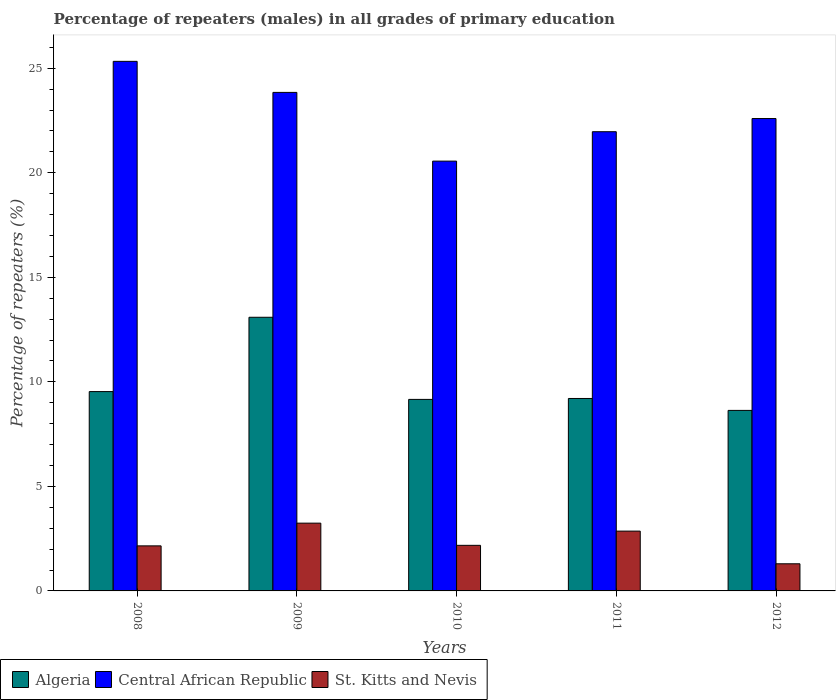How many groups of bars are there?
Ensure brevity in your answer.  5. Are the number of bars on each tick of the X-axis equal?
Your answer should be very brief. Yes. How many bars are there on the 3rd tick from the left?
Keep it short and to the point. 3. What is the label of the 5th group of bars from the left?
Your answer should be compact. 2012. What is the percentage of repeaters (males) in Algeria in 2009?
Your answer should be very brief. 13.09. Across all years, what is the maximum percentage of repeaters (males) in St. Kitts and Nevis?
Ensure brevity in your answer.  3.24. Across all years, what is the minimum percentage of repeaters (males) in St. Kitts and Nevis?
Ensure brevity in your answer.  1.3. In which year was the percentage of repeaters (males) in Central African Republic minimum?
Offer a very short reply. 2010. What is the total percentage of repeaters (males) in Central African Republic in the graph?
Ensure brevity in your answer.  114.28. What is the difference between the percentage of repeaters (males) in Algeria in 2008 and that in 2010?
Keep it short and to the point. 0.37. What is the difference between the percentage of repeaters (males) in Central African Republic in 2011 and the percentage of repeaters (males) in St. Kitts and Nevis in 2012?
Give a very brief answer. 20.66. What is the average percentage of repeaters (males) in Central African Republic per year?
Keep it short and to the point. 22.86. In the year 2008, what is the difference between the percentage of repeaters (males) in St. Kitts and Nevis and percentage of repeaters (males) in Central African Republic?
Give a very brief answer. -23.17. What is the ratio of the percentage of repeaters (males) in Central African Republic in 2008 to that in 2012?
Your answer should be compact. 1.12. Is the difference between the percentage of repeaters (males) in St. Kitts and Nevis in 2009 and 2011 greater than the difference between the percentage of repeaters (males) in Central African Republic in 2009 and 2011?
Provide a succinct answer. No. What is the difference between the highest and the second highest percentage of repeaters (males) in Algeria?
Provide a short and direct response. 3.55. What is the difference between the highest and the lowest percentage of repeaters (males) in St. Kitts and Nevis?
Your answer should be compact. 1.94. Is the sum of the percentage of repeaters (males) in St. Kitts and Nevis in 2008 and 2009 greater than the maximum percentage of repeaters (males) in Algeria across all years?
Your response must be concise. No. What does the 2nd bar from the left in 2010 represents?
Offer a terse response. Central African Republic. What does the 1st bar from the right in 2010 represents?
Provide a succinct answer. St. Kitts and Nevis. Are the values on the major ticks of Y-axis written in scientific E-notation?
Offer a very short reply. No. How are the legend labels stacked?
Offer a terse response. Horizontal. What is the title of the graph?
Make the answer very short. Percentage of repeaters (males) in all grades of primary education. Does "Albania" appear as one of the legend labels in the graph?
Make the answer very short. No. What is the label or title of the Y-axis?
Provide a succinct answer. Percentage of repeaters (%). What is the Percentage of repeaters (%) of Algeria in 2008?
Offer a very short reply. 9.53. What is the Percentage of repeaters (%) of Central African Republic in 2008?
Your answer should be very brief. 25.33. What is the Percentage of repeaters (%) in St. Kitts and Nevis in 2008?
Your answer should be compact. 2.15. What is the Percentage of repeaters (%) of Algeria in 2009?
Your answer should be very brief. 13.09. What is the Percentage of repeaters (%) of Central African Republic in 2009?
Ensure brevity in your answer.  23.84. What is the Percentage of repeaters (%) of St. Kitts and Nevis in 2009?
Provide a short and direct response. 3.24. What is the Percentage of repeaters (%) of Algeria in 2010?
Provide a short and direct response. 9.16. What is the Percentage of repeaters (%) in Central African Republic in 2010?
Ensure brevity in your answer.  20.56. What is the Percentage of repeaters (%) in St. Kitts and Nevis in 2010?
Give a very brief answer. 2.18. What is the Percentage of repeaters (%) in Algeria in 2011?
Provide a succinct answer. 9.2. What is the Percentage of repeaters (%) in Central African Republic in 2011?
Ensure brevity in your answer.  21.96. What is the Percentage of repeaters (%) in St. Kitts and Nevis in 2011?
Give a very brief answer. 2.86. What is the Percentage of repeaters (%) in Algeria in 2012?
Provide a succinct answer. 8.63. What is the Percentage of repeaters (%) of Central African Republic in 2012?
Provide a succinct answer. 22.59. What is the Percentage of repeaters (%) of St. Kitts and Nevis in 2012?
Your answer should be compact. 1.3. Across all years, what is the maximum Percentage of repeaters (%) of Algeria?
Your answer should be very brief. 13.09. Across all years, what is the maximum Percentage of repeaters (%) in Central African Republic?
Keep it short and to the point. 25.33. Across all years, what is the maximum Percentage of repeaters (%) in St. Kitts and Nevis?
Keep it short and to the point. 3.24. Across all years, what is the minimum Percentage of repeaters (%) in Algeria?
Keep it short and to the point. 8.63. Across all years, what is the minimum Percentage of repeaters (%) in Central African Republic?
Keep it short and to the point. 20.56. Across all years, what is the minimum Percentage of repeaters (%) of St. Kitts and Nevis?
Ensure brevity in your answer.  1.3. What is the total Percentage of repeaters (%) of Algeria in the graph?
Provide a succinct answer. 49.62. What is the total Percentage of repeaters (%) in Central African Republic in the graph?
Provide a succinct answer. 114.28. What is the total Percentage of repeaters (%) in St. Kitts and Nevis in the graph?
Your answer should be very brief. 11.73. What is the difference between the Percentage of repeaters (%) in Algeria in 2008 and that in 2009?
Your answer should be compact. -3.55. What is the difference between the Percentage of repeaters (%) of Central African Republic in 2008 and that in 2009?
Keep it short and to the point. 1.48. What is the difference between the Percentage of repeaters (%) of St. Kitts and Nevis in 2008 and that in 2009?
Your answer should be very brief. -1.09. What is the difference between the Percentage of repeaters (%) in Algeria in 2008 and that in 2010?
Your answer should be very brief. 0.37. What is the difference between the Percentage of repeaters (%) of Central African Republic in 2008 and that in 2010?
Give a very brief answer. 4.77. What is the difference between the Percentage of repeaters (%) of St. Kitts and Nevis in 2008 and that in 2010?
Your answer should be very brief. -0.03. What is the difference between the Percentage of repeaters (%) of Algeria in 2008 and that in 2011?
Offer a very short reply. 0.33. What is the difference between the Percentage of repeaters (%) of Central African Republic in 2008 and that in 2011?
Keep it short and to the point. 3.36. What is the difference between the Percentage of repeaters (%) in St. Kitts and Nevis in 2008 and that in 2011?
Your answer should be very brief. -0.71. What is the difference between the Percentage of repeaters (%) in Algeria in 2008 and that in 2012?
Give a very brief answer. 0.9. What is the difference between the Percentage of repeaters (%) of Central African Republic in 2008 and that in 2012?
Provide a succinct answer. 2.73. What is the difference between the Percentage of repeaters (%) of St. Kitts and Nevis in 2008 and that in 2012?
Keep it short and to the point. 0.86. What is the difference between the Percentage of repeaters (%) in Algeria in 2009 and that in 2010?
Your answer should be compact. 3.93. What is the difference between the Percentage of repeaters (%) of Central African Republic in 2009 and that in 2010?
Make the answer very short. 3.29. What is the difference between the Percentage of repeaters (%) of St. Kitts and Nevis in 2009 and that in 2010?
Give a very brief answer. 1.06. What is the difference between the Percentage of repeaters (%) of Algeria in 2009 and that in 2011?
Offer a terse response. 3.88. What is the difference between the Percentage of repeaters (%) of Central African Republic in 2009 and that in 2011?
Keep it short and to the point. 1.88. What is the difference between the Percentage of repeaters (%) of St. Kitts and Nevis in 2009 and that in 2011?
Make the answer very short. 0.38. What is the difference between the Percentage of repeaters (%) in Algeria in 2009 and that in 2012?
Keep it short and to the point. 4.45. What is the difference between the Percentage of repeaters (%) of Central African Republic in 2009 and that in 2012?
Your answer should be very brief. 1.25. What is the difference between the Percentage of repeaters (%) of St. Kitts and Nevis in 2009 and that in 2012?
Make the answer very short. 1.94. What is the difference between the Percentage of repeaters (%) in Algeria in 2010 and that in 2011?
Make the answer very short. -0.04. What is the difference between the Percentage of repeaters (%) in Central African Republic in 2010 and that in 2011?
Provide a short and direct response. -1.41. What is the difference between the Percentage of repeaters (%) in St. Kitts and Nevis in 2010 and that in 2011?
Offer a terse response. -0.68. What is the difference between the Percentage of repeaters (%) of Algeria in 2010 and that in 2012?
Offer a terse response. 0.53. What is the difference between the Percentage of repeaters (%) of Central African Republic in 2010 and that in 2012?
Give a very brief answer. -2.04. What is the difference between the Percentage of repeaters (%) of St. Kitts and Nevis in 2010 and that in 2012?
Keep it short and to the point. 0.88. What is the difference between the Percentage of repeaters (%) in Algeria in 2011 and that in 2012?
Offer a terse response. 0.57. What is the difference between the Percentage of repeaters (%) in Central African Republic in 2011 and that in 2012?
Give a very brief answer. -0.63. What is the difference between the Percentage of repeaters (%) of St. Kitts and Nevis in 2011 and that in 2012?
Your response must be concise. 1.56. What is the difference between the Percentage of repeaters (%) in Algeria in 2008 and the Percentage of repeaters (%) in Central African Republic in 2009?
Your answer should be compact. -14.31. What is the difference between the Percentage of repeaters (%) of Algeria in 2008 and the Percentage of repeaters (%) of St. Kitts and Nevis in 2009?
Your answer should be very brief. 6.29. What is the difference between the Percentage of repeaters (%) of Central African Republic in 2008 and the Percentage of repeaters (%) of St. Kitts and Nevis in 2009?
Your answer should be compact. 22.09. What is the difference between the Percentage of repeaters (%) in Algeria in 2008 and the Percentage of repeaters (%) in Central African Republic in 2010?
Offer a terse response. -11.02. What is the difference between the Percentage of repeaters (%) of Algeria in 2008 and the Percentage of repeaters (%) of St. Kitts and Nevis in 2010?
Your answer should be very brief. 7.35. What is the difference between the Percentage of repeaters (%) in Central African Republic in 2008 and the Percentage of repeaters (%) in St. Kitts and Nevis in 2010?
Offer a very short reply. 23.15. What is the difference between the Percentage of repeaters (%) of Algeria in 2008 and the Percentage of repeaters (%) of Central African Republic in 2011?
Ensure brevity in your answer.  -12.43. What is the difference between the Percentage of repeaters (%) of Algeria in 2008 and the Percentage of repeaters (%) of St. Kitts and Nevis in 2011?
Keep it short and to the point. 6.67. What is the difference between the Percentage of repeaters (%) in Central African Republic in 2008 and the Percentage of repeaters (%) in St. Kitts and Nevis in 2011?
Provide a succinct answer. 22.47. What is the difference between the Percentage of repeaters (%) of Algeria in 2008 and the Percentage of repeaters (%) of Central African Republic in 2012?
Keep it short and to the point. -13.06. What is the difference between the Percentage of repeaters (%) of Algeria in 2008 and the Percentage of repeaters (%) of St. Kitts and Nevis in 2012?
Offer a terse response. 8.24. What is the difference between the Percentage of repeaters (%) of Central African Republic in 2008 and the Percentage of repeaters (%) of St. Kitts and Nevis in 2012?
Your answer should be very brief. 24.03. What is the difference between the Percentage of repeaters (%) in Algeria in 2009 and the Percentage of repeaters (%) in Central African Republic in 2010?
Offer a very short reply. -7.47. What is the difference between the Percentage of repeaters (%) in Algeria in 2009 and the Percentage of repeaters (%) in St. Kitts and Nevis in 2010?
Keep it short and to the point. 10.91. What is the difference between the Percentage of repeaters (%) of Central African Republic in 2009 and the Percentage of repeaters (%) of St. Kitts and Nevis in 2010?
Provide a short and direct response. 21.66. What is the difference between the Percentage of repeaters (%) in Algeria in 2009 and the Percentage of repeaters (%) in Central African Republic in 2011?
Make the answer very short. -8.88. What is the difference between the Percentage of repeaters (%) in Algeria in 2009 and the Percentage of repeaters (%) in St. Kitts and Nevis in 2011?
Your answer should be compact. 10.23. What is the difference between the Percentage of repeaters (%) in Central African Republic in 2009 and the Percentage of repeaters (%) in St. Kitts and Nevis in 2011?
Your answer should be compact. 20.98. What is the difference between the Percentage of repeaters (%) in Algeria in 2009 and the Percentage of repeaters (%) in Central African Republic in 2012?
Offer a very short reply. -9.5. What is the difference between the Percentage of repeaters (%) of Algeria in 2009 and the Percentage of repeaters (%) of St. Kitts and Nevis in 2012?
Make the answer very short. 11.79. What is the difference between the Percentage of repeaters (%) in Central African Republic in 2009 and the Percentage of repeaters (%) in St. Kitts and Nevis in 2012?
Your answer should be very brief. 22.54. What is the difference between the Percentage of repeaters (%) of Algeria in 2010 and the Percentage of repeaters (%) of Central African Republic in 2011?
Offer a very short reply. -12.8. What is the difference between the Percentage of repeaters (%) in Algeria in 2010 and the Percentage of repeaters (%) in St. Kitts and Nevis in 2011?
Ensure brevity in your answer.  6.3. What is the difference between the Percentage of repeaters (%) of Central African Republic in 2010 and the Percentage of repeaters (%) of St. Kitts and Nevis in 2011?
Your answer should be compact. 17.7. What is the difference between the Percentage of repeaters (%) in Algeria in 2010 and the Percentage of repeaters (%) in Central African Republic in 2012?
Make the answer very short. -13.43. What is the difference between the Percentage of repeaters (%) in Algeria in 2010 and the Percentage of repeaters (%) in St. Kitts and Nevis in 2012?
Your answer should be very brief. 7.86. What is the difference between the Percentage of repeaters (%) of Central African Republic in 2010 and the Percentage of repeaters (%) of St. Kitts and Nevis in 2012?
Keep it short and to the point. 19.26. What is the difference between the Percentage of repeaters (%) of Algeria in 2011 and the Percentage of repeaters (%) of Central African Republic in 2012?
Offer a terse response. -13.39. What is the difference between the Percentage of repeaters (%) of Algeria in 2011 and the Percentage of repeaters (%) of St. Kitts and Nevis in 2012?
Give a very brief answer. 7.91. What is the difference between the Percentage of repeaters (%) in Central African Republic in 2011 and the Percentage of repeaters (%) in St. Kitts and Nevis in 2012?
Your answer should be compact. 20.66. What is the average Percentage of repeaters (%) in Algeria per year?
Offer a very short reply. 9.92. What is the average Percentage of repeaters (%) in Central African Republic per year?
Provide a succinct answer. 22.86. What is the average Percentage of repeaters (%) of St. Kitts and Nevis per year?
Give a very brief answer. 2.35. In the year 2008, what is the difference between the Percentage of repeaters (%) in Algeria and Percentage of repeaters (%) in Central African Republic?
Provide a short and direct response. -15.79. In the year 2008, what is the difference between the Percentage of repeaters (%) in Algeria and Percentage of repeaters (%) in St. Kitts and Nevis?
Make the answer very short. 7.38. In the year 2008, what is the difference between the Percentage of repeaters (%) of Central African Republic and Percentage of repeaters (%) of St. Kitts and Nevis?
Give a very brief answer. 23.17. In the year 2009, what is the difference between the Percentage of repeaters (%) in Algeria and Percentage of repeaters (%) in Central African Republic?
Offer a very short reply. -10.76. In the year 2009, what is the difference between the Percentage of repeaters (%) of Algeria and Percentage of repeaters (%) of St. Kitts and Nevis?
Provide a succinct answer. 9.85. In the year 2009, what is the difference between the Percentage of repeaters (%) in Central African Republic and Percentage of repeaters (%) in St. Kitts and Nevis?
Provide a succinct answer. 20.6. In the year 2010, what is the difference between the Percentage of repeaters (%) of Algeria and Percentage of repeaters (%) of Central African Republic?
Your response must be concise. -11.4. In the year 2010, what is the difference between the Percentage of repeaters (%) of Algeria and Percentage of repeaters (%) of St. Kitts and Nevis?
Your answer should be very brief. 6.98. In the year 2010, what is the difference between the Percentage of repeaters (%) in Central African Republic and Percentage of repeaters (%) in St. Kitts and Nevis?
Make the answer very short. 18.38. In the year 2011, what is the difference between the Percentage of repeaters (%) of Algeria and Percentage of repeaters (%) of Central African Republic?
Your response must be concise. -12.76. In the year 2011, what is the difference between the Percentage of repeaters (%) of Algeria and Percentage of repeaters (%) of St. Kitts and Nevis?
Offer a terse response. 6.34. In the year 2011, what is the difference between the Percentage of repeaters (%) in Central African Republic and Percentage of repeaters (%) in St. Kitts and Nevis?
Give a very brief answer. 19.1. In the year 2012, what is the difference between the Percentage of repeaters (%) of Algeria and Percentage of repeaters (%) of Central African Republic?
Your answer should be very brief. -13.96. In the year 2012, what is the difference between the Percentage of repeaters (%) of Algeria and Percentage of repeaters (%) of St. Kitts and Nevis?
Give a very brief answer. 7.34. In the year 2012, what is the difference between the Percentage of repeaters (%) in Central African Republic and Percentage of repeaters (%) in St. Kitts and Nevis?
Ensure brevity in your answer.  21.29. What is the ratio of the Percentage of repeaters (%) in Algeria in 2008 to that in 2009?
Provide a succinct answer. 0.73. What is the ratio of the Percentage of repeaters (%) in Central African Republic in 2008 to that in 2009?
Provide a short and direct response. 1.06. What is the ratio of the Percentage of repeaters (%) of St. Kitts and Nevis in 2008 to that in 2009?
Your response must be concise. 0.66. What is the ratio of the Percentage of repeaters (%) of Algeria in 2008 to that in 2010?
Your answer should be compact. 1.04. What is the ratio of the Percentage of repeaters (%) in Central African Republic in 2008 to that in 2010?
Offer a very short reply. 1.23. What is the ratio of the Percentage of repeaters (%) of St. Kitts and Nevis in 2008 to that in 2010?
Your answer should be compact. 0.99. What is the ratio of the Percentage of repeaters (%) of Algeria in 2008 to that in 2011?
Ensure brevity in your answer.  1.04. What is the ratio of the Percentage of repeaters (%) in Central African Republic in 2008 to that in 2011?
Ensure brevity in your answer.  1.15. What is the ratio of the Percentage of repeaters (%) in St. Kitts and Nevis in 2008 to that in 2011?
Ensure brevity in your answer.  0.75. What is the ratio of the Percentage of repeaters (%) of Algeria in 2008 to that in 2012?
Provide a short and direct response. 1.1. What is the ratio of the Percentage of repeaters (%) in Central African Republic in 2008 to that in 2012?
Give a very brief answer. 1.12. What is the ratio of the Percentage of repeaters (%) in St. Kitts and Nevis in 2008 to that in 2012?
Keep it short and to the point. 1.66. What is the ratio of the Percentage of repeaters (%) in Algeria in 2009 to that in 2010?
Offer a very short reply. 1.43. What is the ratio of the Percentage of repeaters (%) of Central African Republic in 2009 to that in 2010?
Offer a terse response. 1.16. What is the ratio of the Percentage of repeaters (%) of St. Kitts and Nevis in 2009 to that in 2010?
Keep it short and to the point. 1.49. What is the ratio of the Percentage of repeaters (%) of Algeria in 2009 to that in 2011?
Provide a succinct answer. 1.42. What is the ratio of the Percentage of repeaters (%) in Central African Republic in 2009 to that in 2011?
Offer a terse response. 1.09. What is the ratio of the Percentage of repeaters (%) of St. Kitts and Nevis in 2009 to that in 2011?
Offer a terse response. 1.13. What is the ratio of the Percentage of repeaters (%) in Algeria in 2009 to that in 2012?
Provide a succinct answer. 1.52. What is the ratio of the Percentage of repeaters (%) in Central African Republic in 2009 to that in 2012?
Offer a terse response. 1.06. What is the ratio of the Percentage of repeaters (%) in St. Kitts and Nevis in 2009 to that in 2012?
Your answer should be compact. 2.5. What is the ratio of the Percentage of repeaters (%) of Algeria in 2010 to that in 2011?
Keep it short and to the point. 1. What is the ratio of the Percentage of repeaters (%) in Central African Republic in 2010 to that in 2011?
Keep it short and to the point. 0.94. What is the ratio of the Percentage of repeaters (%) in St. Kitts and Nevis in 2010 to that in 2011?
Your answer should be compact. 0.76. What is the ratio of the Percentage of repeaters (%) of Algeria in 2010 to that in 2012?
Your answer should be very brief. 1.06. What is the ratio of the Percentage of repeaters (%) of Central African Republic in 2010 to that in 2012?
Keep it short and to the point. 0.91. What is the ratio of the Percentage of repeaters (%) of St. Kitts and Nevis in 2010 to that in 2012?
Make the answer very short. 1.68. What is the ratio of the Percentage of repeaters (%) of Algeria in 2011 to that in 2012?
Offer a very short reply. 1.07. What is the ratio of the Percentage of repeaters (%) of Central African Republic in 2011 to that in 2012?
Provide a succinct answer. 0.97. What is the ratio of the Percentage of repeaters (%) in St. Kitts and Nevis in 2011 to that in 2012?
Provide a succinct answer. 2.2. What is the difference between the highest and the second highest Percentage of repeaters (%) in Algeria?
Your response must be concise. 3.55. What is the difference between the highest and the second highest Percentage of repeaters (%) in Central African Republic?
Give a very brief answer. 1.48. What is the difference between the highest and the second highest Percentage of repeaters (%) in St. Kitts and Nevis?
Ensure brevity in your answer.  0.38. What is the difference between the highest and the lowest Percentage of repeaters (%) of Algeria?
Keep it short and to the point. 4.45. What is the difference between the highest and the lowest Percentage of repeaters (%) in Central African Republic?
Keep it short and to the point. 4.77. What is the difference between the highest and the lowest Percentage of repeaters (%) in St. Kitts and Nevis?
Provide a succinct answer. 1.94. 